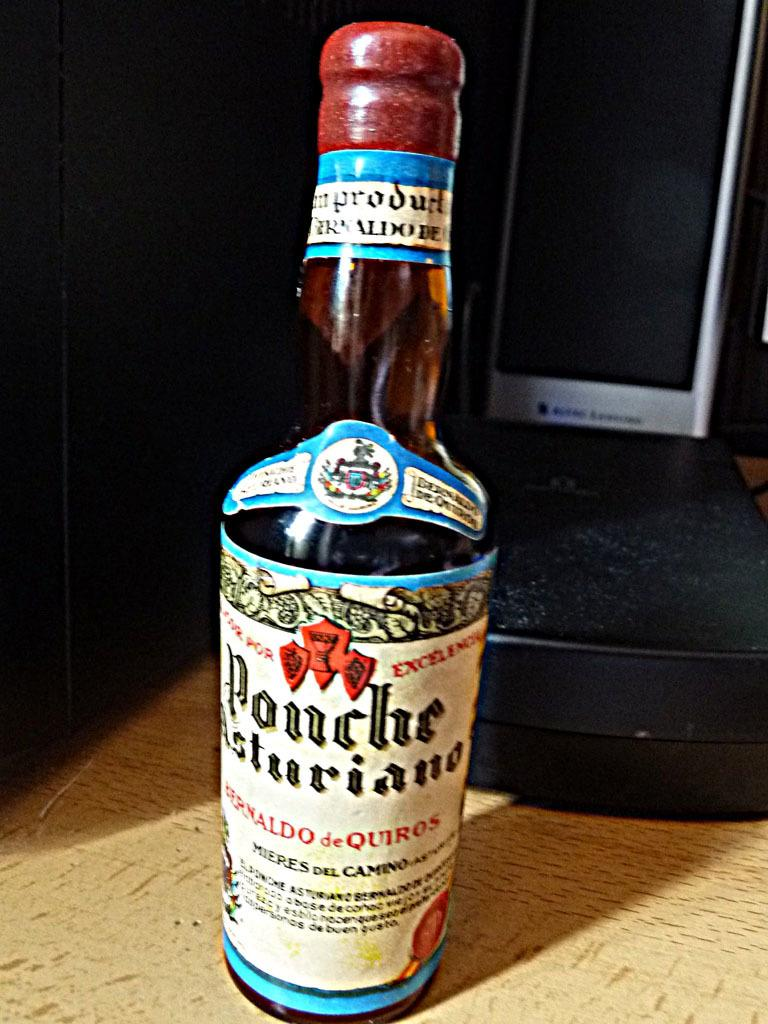<image>
Describe the image concisely. A bottle of Ponche sitting on the floor. 